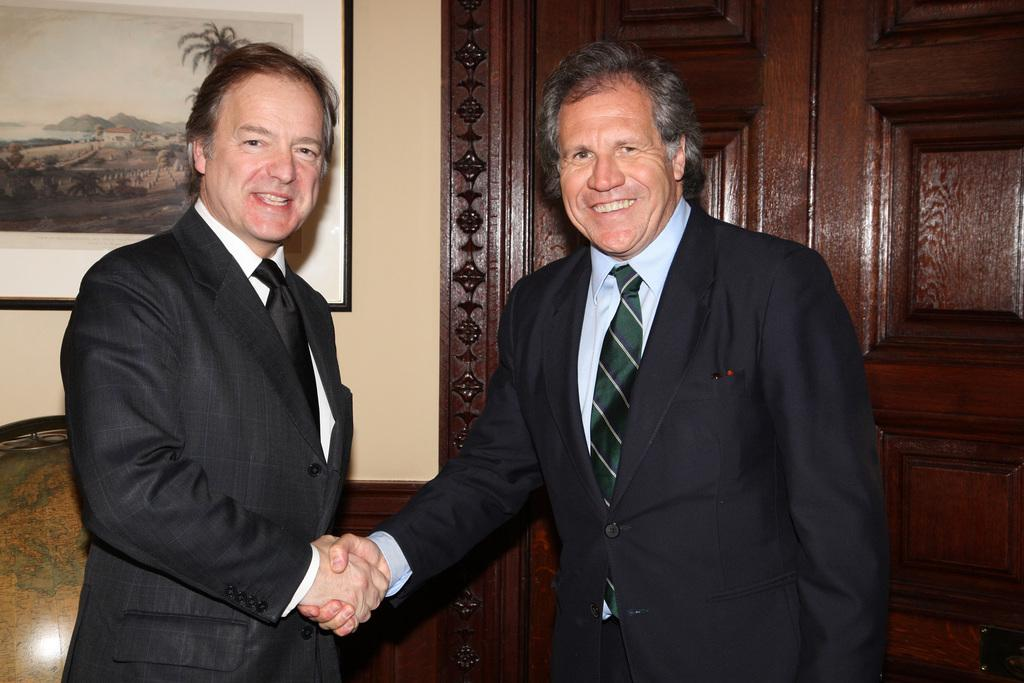How many people are in the foreground of the image? There are two persons in the foreground of the image. What are the people in the image doing? The persons are smiling and shaking hands with each other. What can be seen in the background of the image? There is a door, a photo frame, a globe, and a wall in the background of the image. What type of control panel can be seen on the plane in the image? There is no plane present in the image; it features two people shaking hands in the foreground and various objects in the background. What is the basin used for in the image? There is no basin present in the image. 